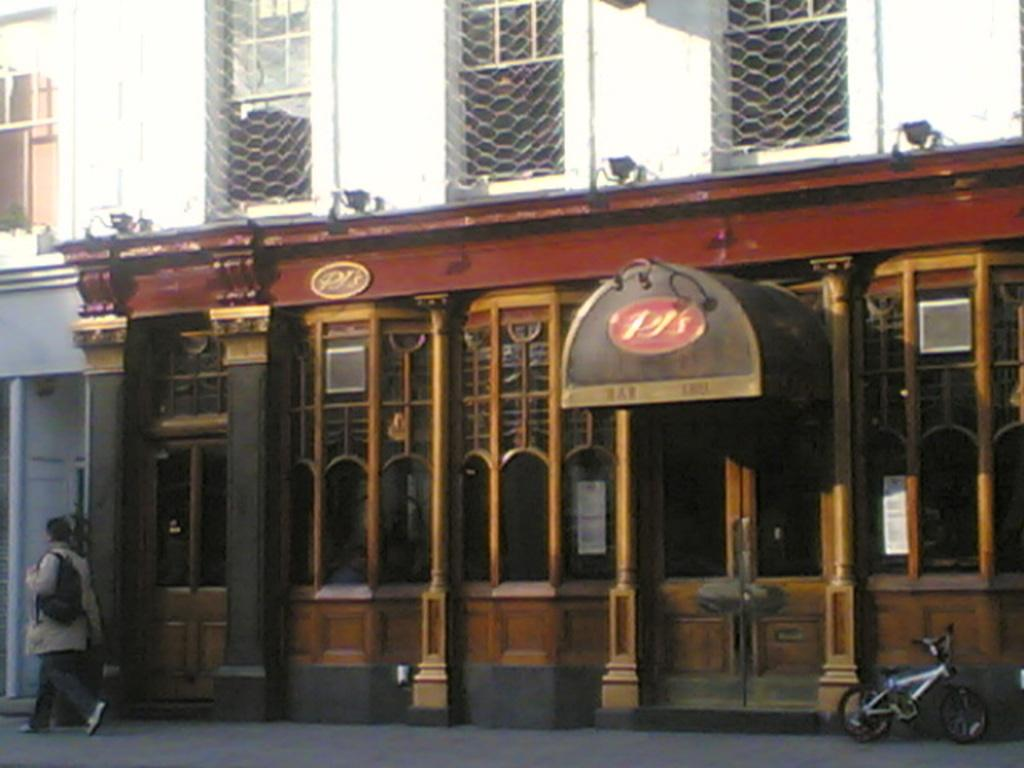What type of structure is visible in the image? There is a building in the image. What can be seen on the sidewalk near the building? There is a bicycle on the sidewalk. What is the person in the image doing? A human is walking in the image. What might the person be carrying in their hand? The person is holding a bag. How far away is the spy from the building in the image? There is no spy present in the image, so it is not possible to determine the distance between a spy and the building. Can you tell me how many chickens are visible in the image? There are no chickens present in the image. 